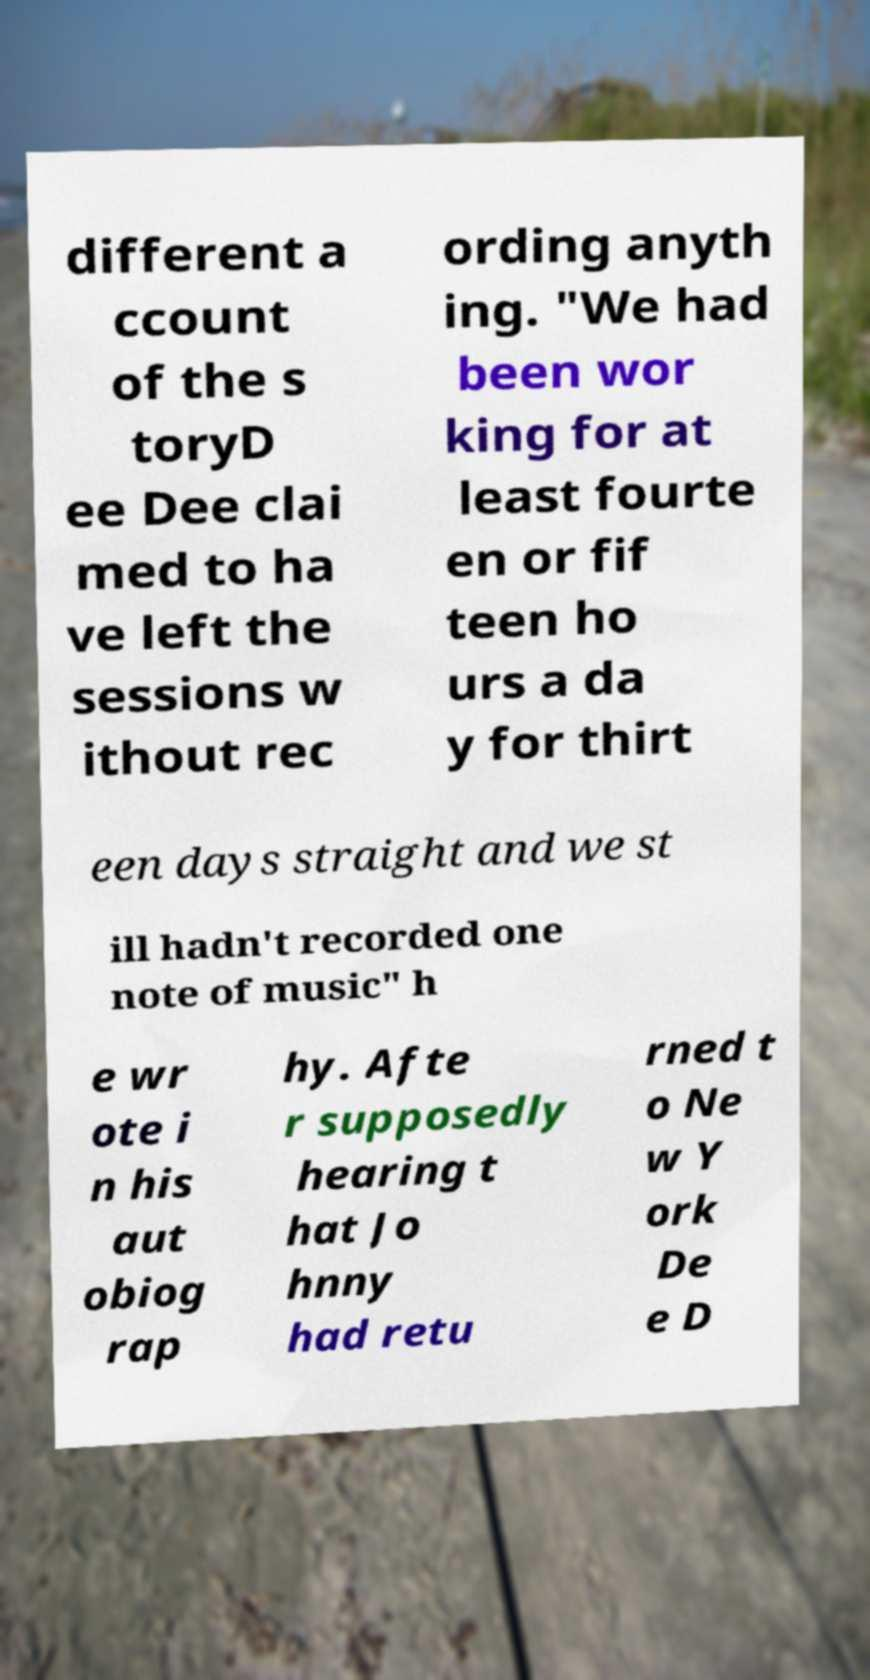Please identify and transcribe the text found in this image. different a ccount of the s toryD ee Dee clai med to ha ve left the sessions w ithout rec ording anyth ing. "We had been wor king for at least fourte en or fif teen ho urs a da y for thirt een days straight and we st ill hadn't recorded one note of music" h e wr ote i n his aut obiog rap hy. Afte r supposedly hearing t hat Jo hnny had retu rned t o Ne w Y ork De e D 